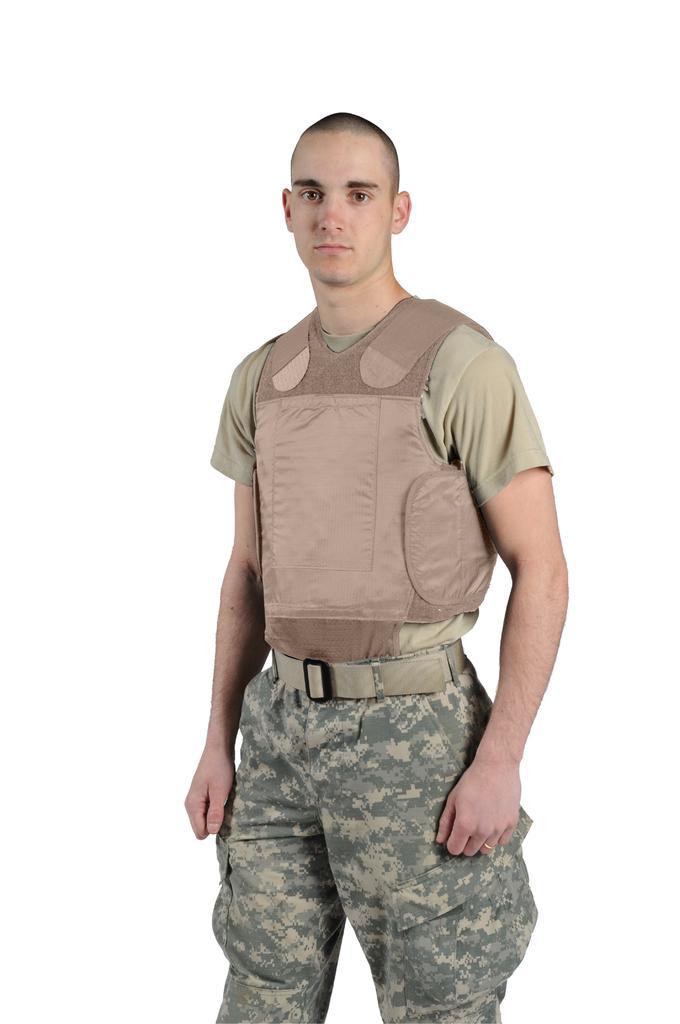Please provide a concise description of this image. In this image the background is white in color. In the middle of the image there is a man. 